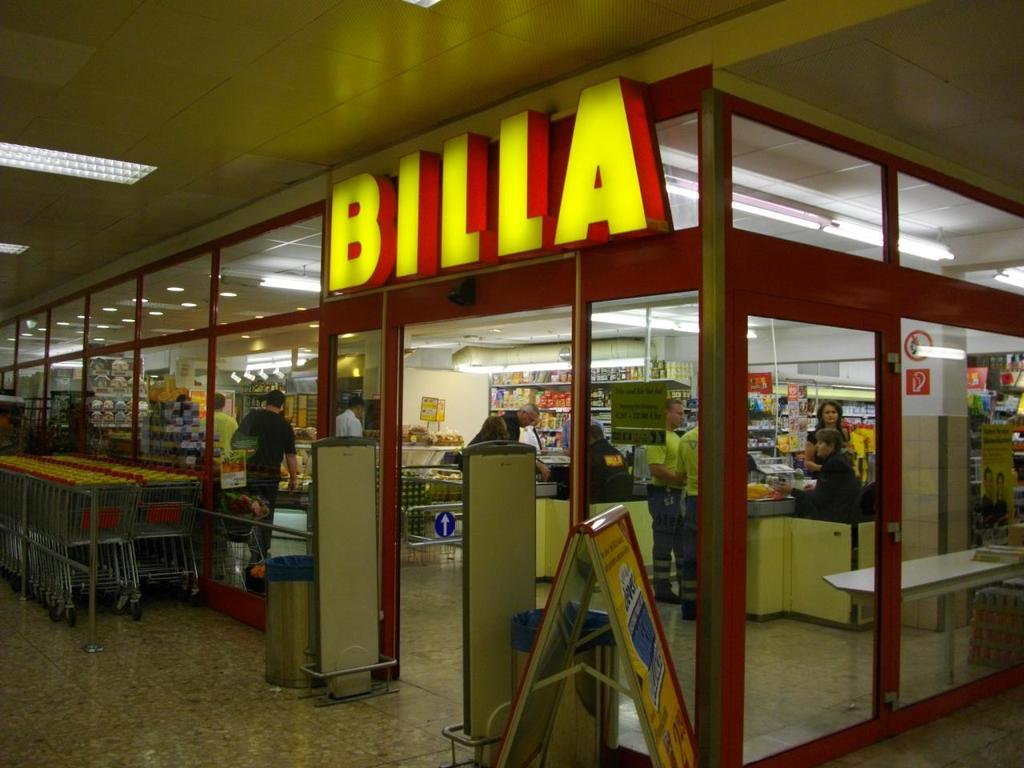<image>
Give a short and clear explanation of the subsequent image. Shopping carts are available right outside the doors to Billa. 